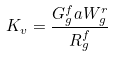<formula> <loc_0><loc_0><loc_500><loc_500>K _ { v } = \frac { G _ { g } ^ { f } a W _ { g } ^ { r } } { R _ { g } ^ { f } }</formula> 